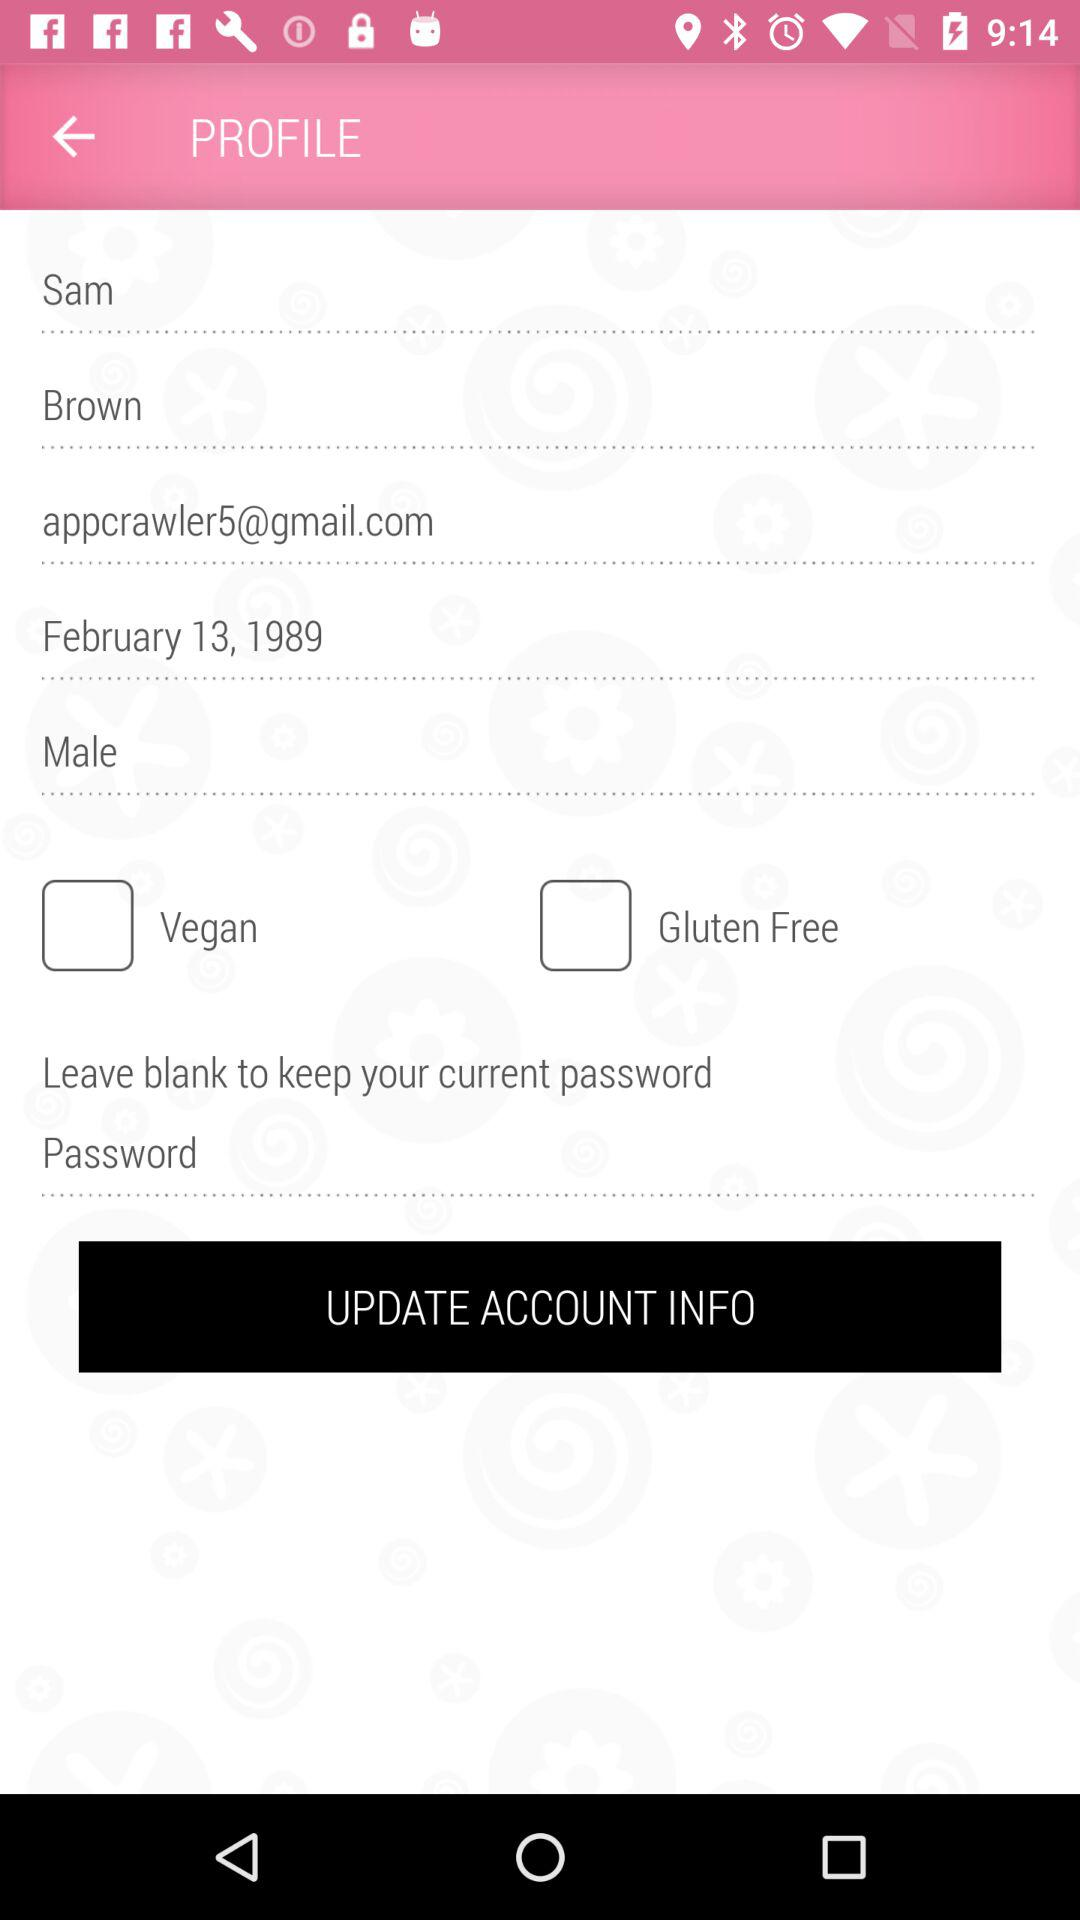Where does Sam Brown live?
When the provided information is insufficient, respond with <no answer>. <no answer> 